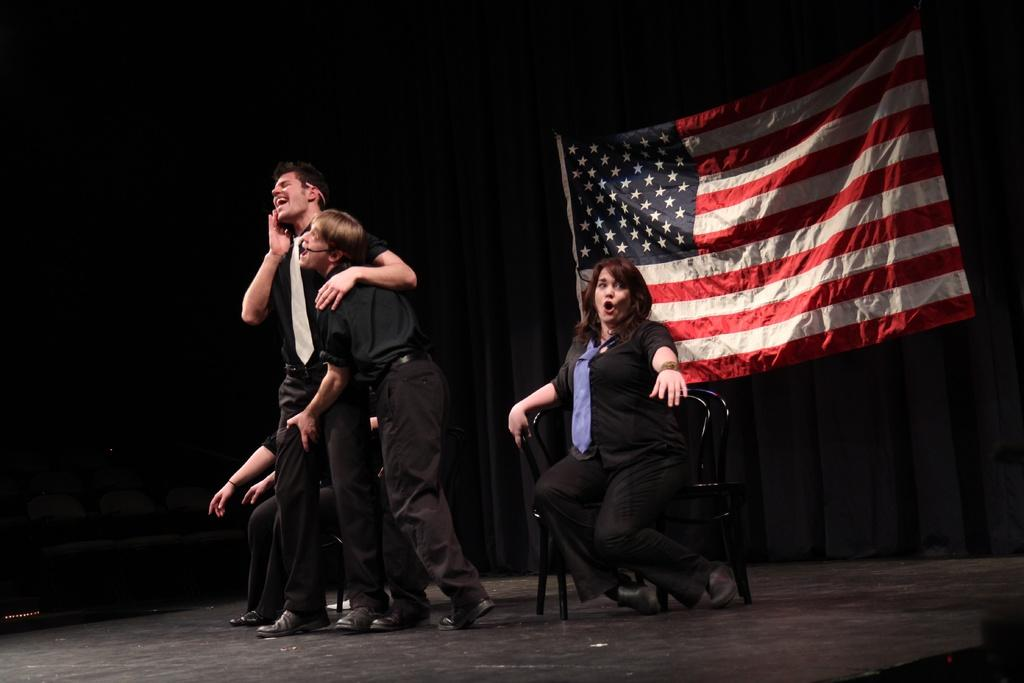What is happening on the stage in the image? There are people on a stage in the image, and they are performing a play. What positions are the people on the stage in? The people are either sitting or standing. What can be seen on the wall behind the stage? There is a flag on the wall behind the stage. What type of underwear is the actor wearing in the image? There is no information about the actors' underwear in the image, and it is not visible. 